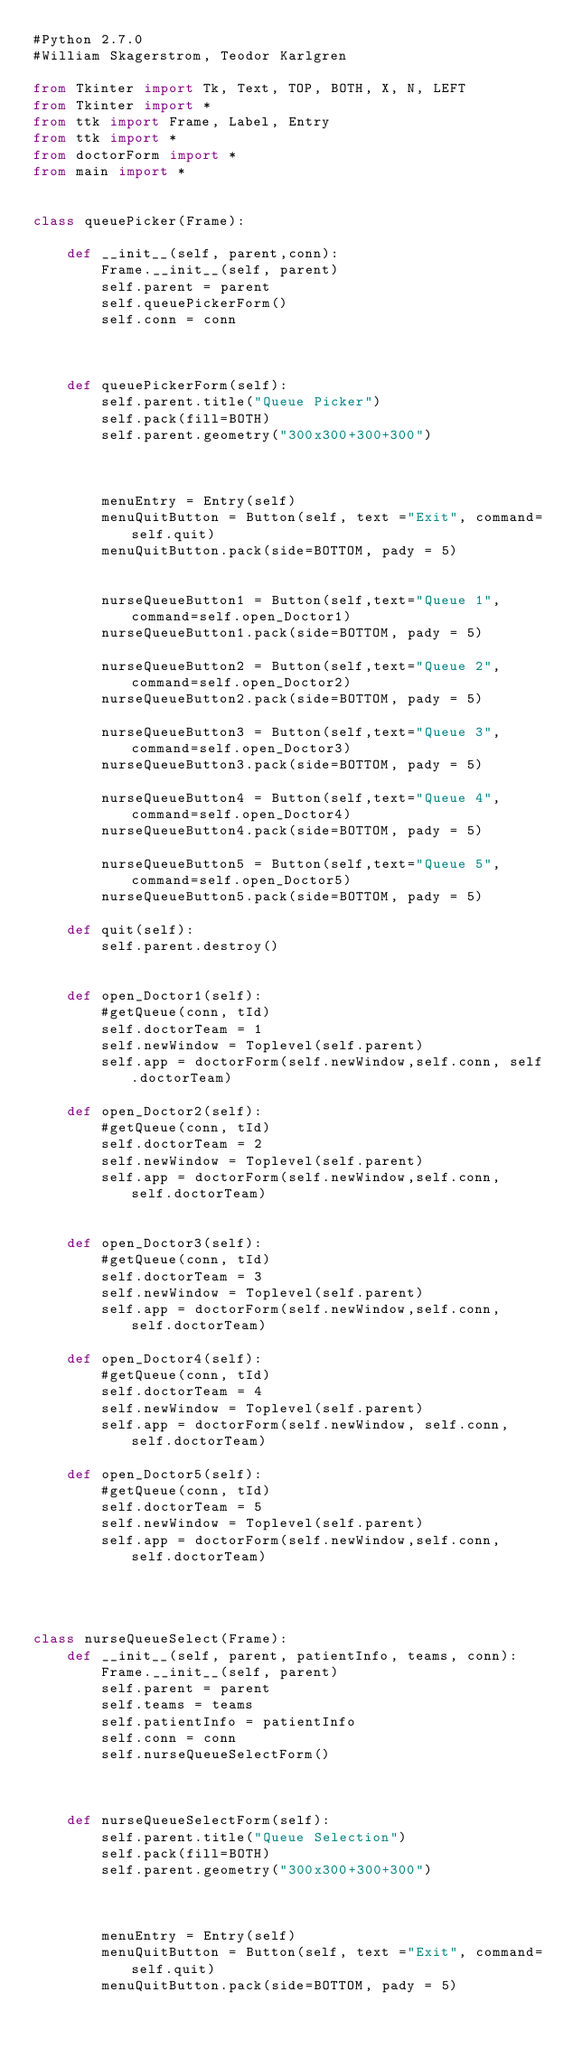Convert code to text. <code><loc_0><loc_0><loc_500><loc_500><_Python_>#Python 2.7.0
#William Skagerstrom, Teodor Karlgren

from Tkinter import Tk, Text, TOP, BOTH, X, N, LEFT
from Tkinter import *
from ttk import Frame, Label, Entry
from ttk import *
from doctorForm import *
from main import *


class queuePicker(Frame):

    def __init__(self, parent,conn):
        Frame.__init__(self, parent)
        self.parent = parent
        self.queuePickerForm()
        self.conn = conn



    def queuePickerForm(self):
        self.parent.title("Queue Picker")
        self.pack(fill=BOTH)
        self.parent.geometry("300x300+300+300")



        menuEntry = Entry(self)
        menuQuitButton = Button(self, text ="Exit", command=self.quit)
        menuQuitButton.pack(side=BOTTOM, pady = 5)


        nurseQueueButton1 = Button(self,text="Queue 1", command=self.open_Doctor1)
        nurseQueueButton1.pack(side=BOTTOM, pady = 5)

        nurseQueueButton2 = Button(self,text="Queue 2", command=self.open_Doctor2)
        nurseQueueButton2.pack(side=BOTTOM, pady = 5)

        nurseQueueButton3 = Button(self,text="Queue 3", command=self.open_Doctor3)
        nurseQueueButton3.pack(side=BOTTOM, pady = 5)

        nurseQueueButton4 = Button(self,text="Queue 4", command=self.open_Doctor4)
        nurseQueueButton4.pack(side=BOTTOM, pady = 5)

        nurseQueueButton5 = Button(self,text="Queue 5", command=self.open_Doctor5)
        nurseQueueButton5.pack(side=BOTTOM, pady = 5)

    def quit(self):
        self.parent.destroy()


    def open_Doctor1(self):
        #getQueue(conn, tId)
        self.doctorTeam = 1
        self.newWindow = Toplevel(self.parent)
        self.app = doctorForm(self.newWindow,self.conn, self.doctorTeam)

    def open_Doctor2(self):
        #getQueue(conn, tId)
        self.doctorTeam = 2
        self.newWindow = Toplevel(self.parent)
        self.app = doctorForm(self.newWindow,self.conn,  self.doctorTeam)


    def open_Doctor3(self):
        #getQueue(conn, tId)
        self.doctorTeam = 3
        self.newWindow = Toplevel(self.parent)
        self.app = doctorForm(self.newWindow,self.conn,  self.doctorTeam)

    def open_Doctor4(self):
        #getQueue(conn, tId)
        self.doctorTeam = 4
        self.newWindow = Toplevel(self.parent)
        self.app = doctorForm(self.newWindow, self.conn, self.doctorTeam)

    def open_Doctor5(self):
        #getQueue(conn, tId)
        self.doctorTeam = 5
        self.newWindow = Toplevel(self.parent)
        self.app = doctorForm(self.newWindow,self.conn,  self.doctorTeam)




class nurseQueueSelect(Frame):
    def __init__(self, parent, patientInfo, teams, conn):
        Frame.__init__(self, parent)
        self.parent = parent
        self.teams = teams
        self.patientInfo = patientInfo
        self.conn = conn
        self.nurseQueueSelectForm()



    def nurseQueueSelectForm(self):
        self.parent.title("Queue Selection")
        self.pack(fill=BOTH)
        self.parent.geometry("300x300+300+300")



        menuEntry = Entry(self)
        menuQuitButton = Button(self, text ="Exit", command=self.quit)
        menuQuitButton.pack(side=BOTTOM, pady = 5)
</code> 